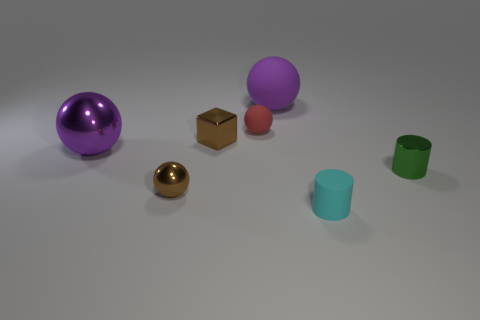Is there any other thing that has the same size as the cyan object?
Provide a succinct answer. Yes. Are there any things behind the cyan object?
Make the answer very short. Yes. There is a small cylinder to the right of the small cyan cylinder; is its color the same as the large object that is to the right of the block?
Ensure brevity in your answer.  No. Are there any tiny green metallic objects that have the same shape as the tiny red matte object?
Give a very brief answer. No. How many other objects are the same color as the big matte object?
Ensure brevity in your answer.  1. What color is the cylinder that is in front of the brown metallic object in front of the cylinder that is behind the brown sphere?
Make the answer very short. Cyan. Are there an equal number of small rubber things that are in front of the metal cube and small cyan cubes?
Ensure brevity in your answer.  No. Do the brown shiny object behind the green shiny cylinder and the large metal thing have the same size?
Keep it short and to the point. No. How many tiny brown blocks are there?
Offer a very short reply. 1. What number of small objects are in front of the brown block and on the left side of the green object?
Provide a short and direct response. 2. 